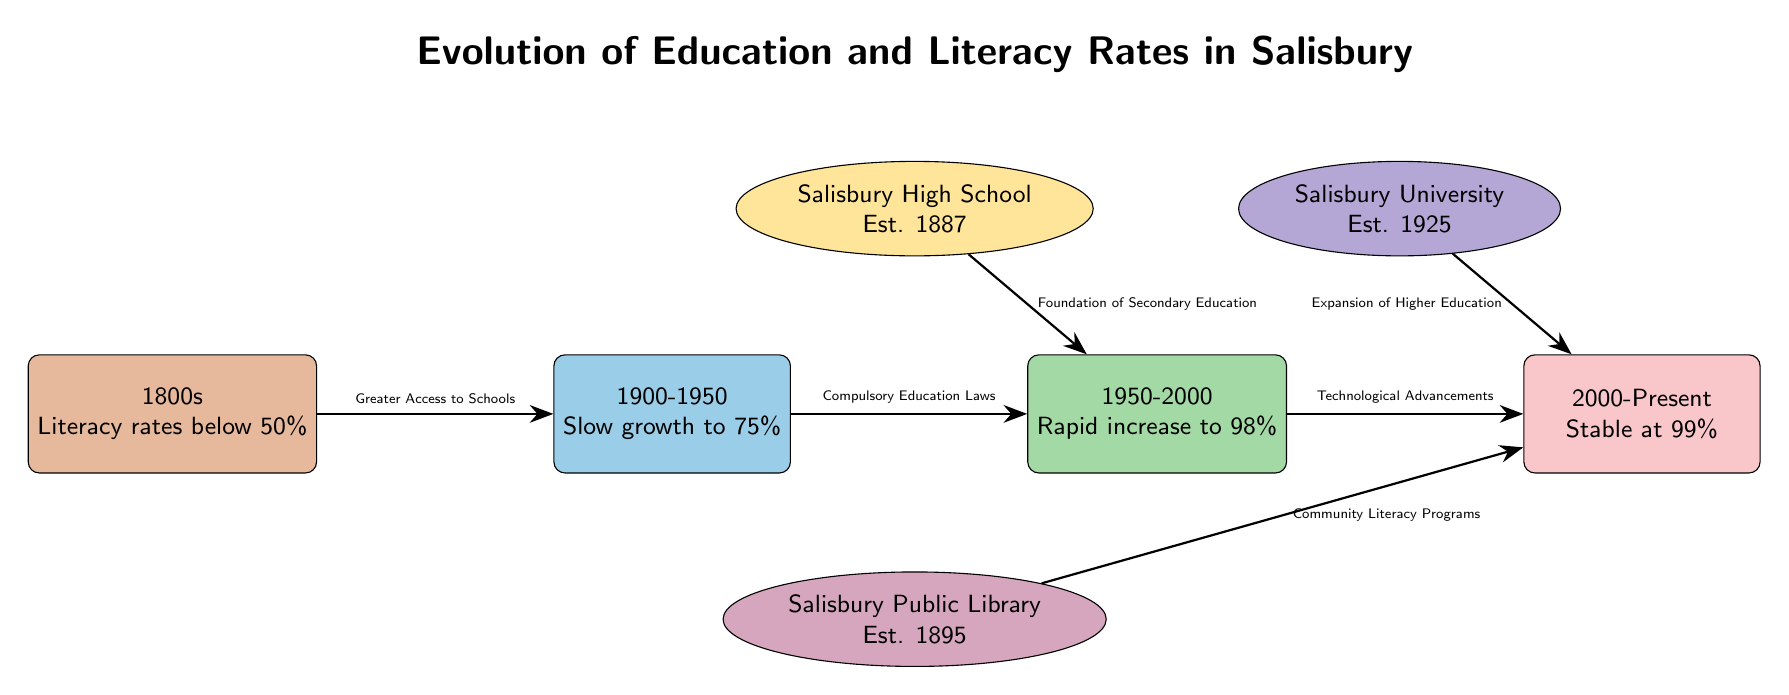What was the literacy rate in the 1800s? The node for the 1800s states that the literacy rates were below 50%. This information is directly stated in the diagram without needing further information.
Answer: below 50% What is the highest literacy rate mentioned in the timeline? According to the node for 2000-present, the literacy rate is stable at 99%. This is the highest rate presented in the diagram.
Answer: 99% What significant educational establishment was founded in 1887? The node labeled "Salisbury High School" contains the establishment year of 1887. This information directly answers the question regarding the significant establishment.
Answer: Salisbury High School What milestone is established in 1925? The node labeled "Salisbury University" shows it was established in 1925. The information is clear and points directly to the year and corresponding establishment.
Answer: Salisbury University What contributed to the rapid increase in literacy from 1950 to 2000? The diagram shows an arrow labeled "Compulsory Education Laws" leading to the increase from 75% to 98% literacy rates between 1900-2000. This connection indicates the impact of compulsory education on literacy.
Answer: Compulsory Education Laws What has been the trend in literacy rates from 1950 to the present? The timeline node from 1950-2000 shows a rapid increase to 98%, followed by a stability at 99% from 2000-present. This indicates overall positive progress in literacy rates during this period.
Answer: Stable at 99% Which establishment supports community literacy programs? The diagram shows an arrow leading from "Salisbury Public Library" to the 2000-present node, indicating its role in supporting community literacy programs during this time.
Answer: Salisbury Public Library How many educational milestones are shown in the diagram? There are three educational milestones indicated in the diagram: Salisbury High School, Salisbury University, and Salisbury Public Library. By counting these nodes, we arrive at the total milestone count.
Answer: 3 What major development in education is indicated between 1950 and 2000? The arrow connecting the 1900-1950 node to 1950-2000 lists "Compulsory Education Laws," indicating a significant development in education that directly impacts literacy rates.
Answer: Compulsory Education Laws 